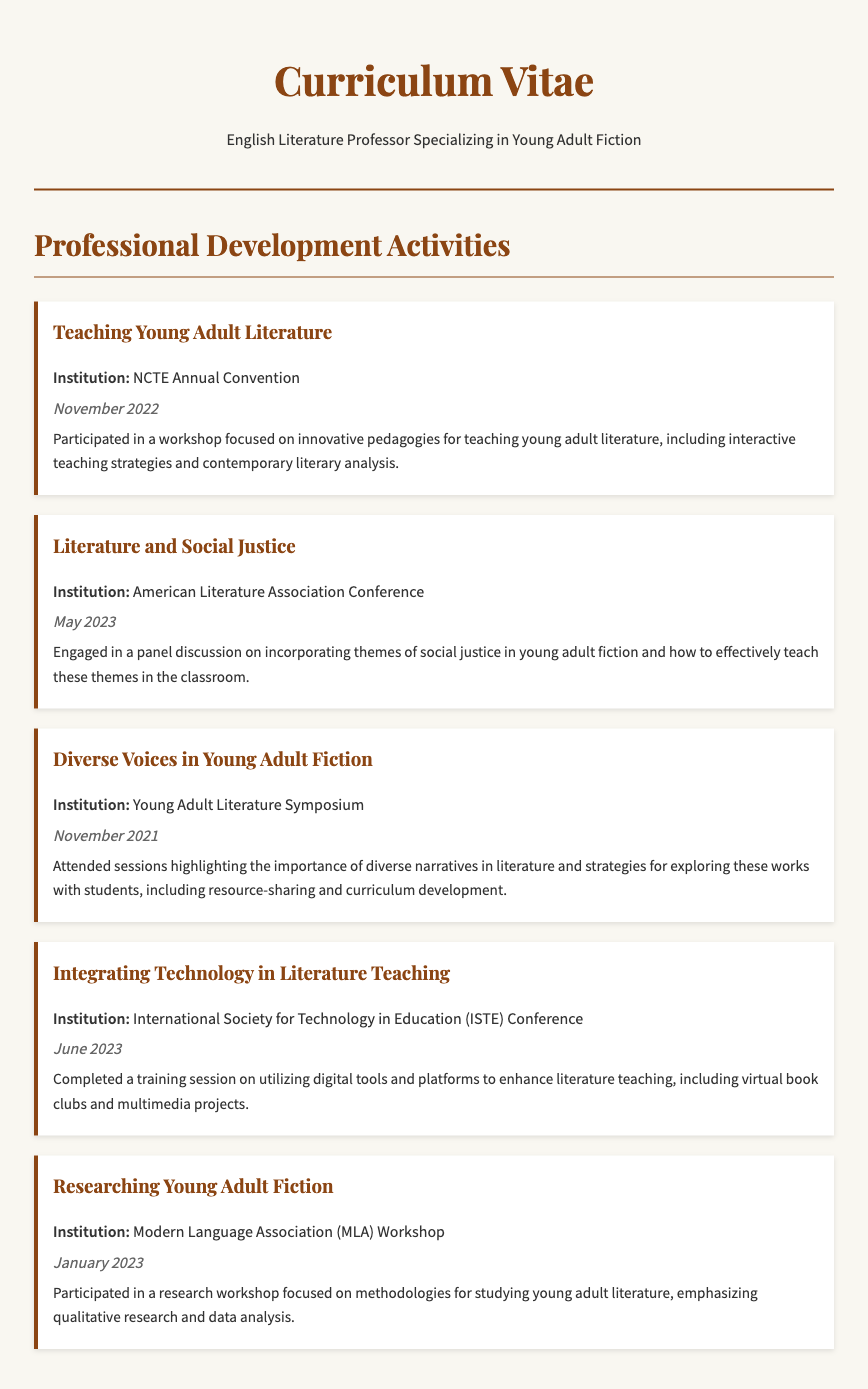What was the title of the workshop attended in November 2022? The title of the workshop can be found in the document under the corresponding date.
Answer: Teaching Young Adult Literature Which institution hosted the panel discussion on literature and social justice? The institution for the panel discussion is specified in the document linked to the event date in May 2023.
Answer: American Literature Association Conference What date did the workshop on integrating technology in literature teaching occur? The date for the technology workshop is mentioned in the event description.
Answer: June 2023 What focus did the "Diverse Voices in Young Adult Fiction" session highlight? The focus of this session is detailed in the description of that particular activity.
Answer: Importance of diverse narratives How many professional development activities are listed in the document? The total number of activities can be counted from the list provided.
Answer: Five Which workshop emphasized methodologies for studying young adult literature? The specific workshop name is mentioned in the description section of the CV.
Answer: Researching Young Adult Fiction What was one of the interactive teaching strategies discussed in the November 2022 workshop? The workshop focused on innovative pedagogies for a specific genre of literature, indicating a range of strategies.
Answer: Interactive teaching strategies What training was completed in January 2023? The document specifically highlights a workshop completed within that timeframe, capturing the context.
Answer: Researching Young Adult Fiction 